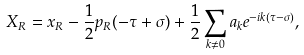<formula> <loc_0><loc_0><loc_500><loc_500>X _ { R } = x _ { R } - \frac { 1 } { 2 } p _ { R } ( - \tau + \sigma ) + \frac { 1 } { 2 } \sum _ { k \neq 0 } a _ { k } e ^ { - i k ( \tau - \sigma ) } ,</formula> 